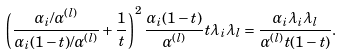<formula> <loc_0><loc_0><loc_500><loc_500>\left ( \frac { \alpha _ { i } / \alpha ^ { ( l ) } } { \alpha _ { i } ( 1 - t ) / \alpha ^ { ( l ) } } + \frac { 1 } { t } \right ) ^ { 2 } \frac { \alpha _ { i } ( 1 - t ) } { \alpha ^ { ( l ) } } t \lambda _ { i } \lambda _ { l } = \frac { \alpha _ { i } \lambda _ { i } \lambda _ { l } } { \alpha ^ { ( l ) } t ( 1 - t ) } .</formula> 